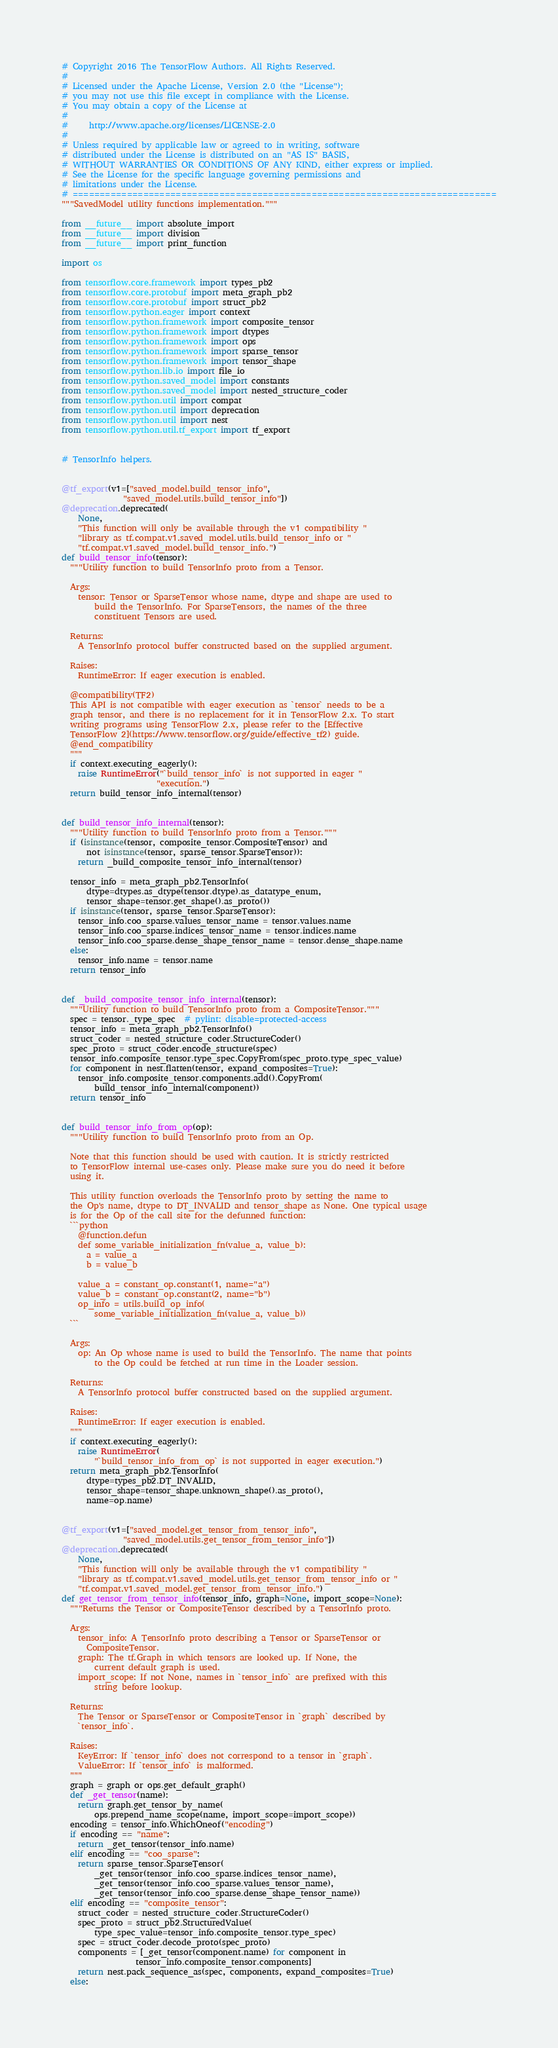<code> <loc_0><loc_0><loc_500><loc_500><_Python_># Copyright 2016 The TensorFlow Authors. All Rights Reserved.
#
# Licensed under the Apache License, Version 2.0 (the "License");
# you may not use this file except in compliance with the License.
# You may obtain a copy of the License at
#
#     http://www.apache.org/licenses/LICENSE-2.0
#
# Unless required by applicable law or agreed to in writing, software
# distributed under the License is distributed on an "AS IS" BASIS,
# WITHOUT WARRANTIES OR CONDITIONS OF ANY KIND, either express or implied.
# See the License for the specific language governing permissions and
# limitations under the License.
# ==============================================================================
"""SavedModel utility functions implementation."""

from __future__ import absolute_import
from __future__ import division
from __future__ import print_function

import os

from tensorflow.core.framework import types_pb2
from tensorflow.core.protobuf import meta_graph_pb2
from tensorflow.core.protobuf import struct_pb2
from tensorflow.python.eager import context
from tensorflow.python.framework import composite_tensor
from tensorflow.python.framework import dtypes
from tensorflow.python.framework import ops
from tensorflow.python.framework import sparse_tensor
from tensorflow.python.framework import tensor_shape
from tensorflow.python.lib.io import file_io
from tensorflow.python.saved_model import constants
from tensorflow.python.saved_model import nested_structure_coder
from tensorflow.python.util import compat
from tensorflow.python.util import deprecation
from tensorflow.python.util import nest
from tensorflow.python.util.tf_export import tf_export


# TensorInfo helpers.


@tf_export(v1=["saved_model.build_tensor_info",
               "saved_model.utils.build_tensor_info"])
@deprecation.deprecated(
    None,
    "This function will only be available through the v1 compatibility "
    "library as tf.compat.v1.saved_model.utils.build_tensor_info or "
    "tf.compat.v1.saved_model.build_tensor_info.")
def build_tensor_info(tensor):
  """Utility function to build TensorInfo proto from a Tensor.

  Args:
    tensor: Tensor or SparseTensor whose name, dtype and shape are used to
        build the TensorInfo. For SparseTensors, the names of the three
        constituent Tensors are used.

  Returns:
    A TensorInfo protocol buffer constructed based on the supplied argument.

  Raises:
    RuntimeError: If eager execution is enabled.

  @compatibility(TF2)
  This API is not compatible with eager execution as `tensor` needs to be a
  graph tensor, and there is no replacement for it in TensorFlow 2.x. To start
  writing programs using TensorFlow 2.x, please refer to the [Effective
  TensorFlow 2](https://www.tensorflow.org/guide/effective_tf2) guide.
  @end_compatibility
  """
  if context.executing_eagerly():
    raise RuntimeError("`build_tensor_info` is not supported in eager "
                       "execution.")
  return build_tensor_info_internal(tensor)


def build_tensor_info_internal(tensor):
  """Utility function to build TensorInfo proto from a Tensor."""
  if (isinstance(tensor, composite_tensor.CompositeTensor) and
      not isinstance(tensor, sparse_tensor.SparseTensor)):
    return _build_composite_tensor_info_internal(tensor)

  tensor_info = meta_graph_pb2.TensorInfo(
      dtype=dtypes.as_dtype(tensor.dtype).as_datatype_enum,
      tensor_shape=tensor.get_shape().as_proto())
  if isinstance(tensor, sparse_tensor.SparseTensor):
    tensor_info.coo_sparse.values_tensor_name = tensor.values.name
    tensor_info.coo_sparse.indices_tensor_name = tensor.indices.name
    tensor_info.coo_sparse.dense_shape_tensor_name = tensor.dense_shape.name
  else:
    tensor_info.name = tensor.name
  return tensor_info


def _build_composite_tensor_info_internal(tensor):
  """Utility function to build TensorInfo proto from a CompositeTensor."""
  spec = tensor._type_spec  # pylint: disable=protected-access
  tensor_info = meta_graph_pb2.TensorInfo()
  struct_coder = nested_structure_coder.StructureCoder()
  spec_proto = struct_coder.encode_structure(spec)
  tensor_info.composite_tensor.type_spec.CopyFrom(spec_proto.type_spec_value)
  for component in nest.flatten(tensor, expand_composites=True):
    tensor_info.composite_tensor.components.add().CopyFrom(
        build_tensor_info_internal(component))
  return tensor_info


def build_tensor_info_from_op(op):
  """Utility function to build TensorInfo proto from an Op.

  Note that this function should be used with caution. It is strictly restricted
  to TensorFlow internal use-cases only. Please make sure you do need it before
  using it.

  This utility function overloads the TensorInfo proto by setting the name to
  the Op's name, dtype to DT_INVALID and tensor_shape as None. One typical usage
  is for the Op of the call site for the defunned function:
  ```python
    @function.defun
    def some_variable_initialization_fn(value_a, value_b):
      a = value_a
      b = value_b

    value_a = constant_op.constant(1, name="a")
    value_b = constant_op.constant(2, name="b")
    op_info = utils.build_op_info(
        some_variable_initialization_fn(value_a, value_b))
  ```

  Args:
    op: An Op whose name is used to build the TensorInfo. The name that points
        to the Op could be fetched at run time in the Loader session.

  Returns:
    A TensorInfo protocol buffer constructed based on the supplied argument.

  Raises:
    RuntimeError: If eager execution is enabled.
  """
  if context.executing_eagerly():
    raise RuntimeError(
        "`build_tensor_info_from_op` is not supported in eager execution.")
  return meta_graph_pb2.TensorInfo(
      dtype=types_pb2.DT_INVALID,
      tensor_shape=tensor_shape.unknown_shape().as_proto(),
      name=op.name)


@tf_export(v1=["saved_model.get_tensor_from_tensor_info",
               "saved_model.utils.get_tensor_from_tensor_info"])
@deprecation.deprecated(
    None,
    "This function will only be available through the v1 compatibility "
    "library as tf.compat.v1.saved_model.utils.get_tensor_from_tensor_info or "
    "tf.compat.v1.saved_model.get_tensor_from_tensor_info.")
def get_tensor_from_tensor_info(tensor_info, graph=None, import_scope=None):
  """Returns the Tensor or CompositeTensor described by a TensorInfo proto.

  Args:
    tensor_info: A TensorInfo proto describing a Tensor or SparseTensor or
      CompositeTensor.
    graph: The tf.Graph in which tensors are looked up. If None, the
        current default graph is used.
    import_scope: If not None, names in `tensor_info` are prefixed with this
        string before lookup.

  Returns:
    The Tensor or SparseTensor or CompositeTensor in `graph` described by
    `tensor_info`.

  Raises:
    KeyError: If `tensor_info` does not correspond to a tensor in `graph`.
    ValueError: If `tensor_info` is malformed.
  """
  graph = graph or ops.get_default_graph()
  def _get_tensor(name):
    return graph.get_tensor_by_name(
        ops.prepend_name_scope(name, import_scope=import_scope))
  encoding = tensor_info.WhichOneof("encoding")
  if encoding == "name":
    return _get_tensor(tensor_info.name)
  elif encoding == "coo_sparse":
    return sparse_tensor.SparseTensor(
        _get_tensor(tensor_info.coo_sparse.indices_tensor_name),
        _get_tensor(tensor_info.coo_sparse.values_tensor_name),
        _get_tensor(tensor_info.coo_sparse.dense_shape_tensor_name))
  elif encoding == "composite_tensor":
    struct_coder = nested_structure_coder.StructureCoder()
    spec_proto = struct_pb2.StructuredValue(
        type_spec_value=tensor_info.composite_tensor.type_spec)
    spec = struct_coder.decode_proto(spec_proto)
    components = [_get_tensor(component.name) for component in
                  tensor_info.composite_tensor.components]
    return nest.pack_sequence_as(spec, components, expand_composites=True)
  else:</code> 